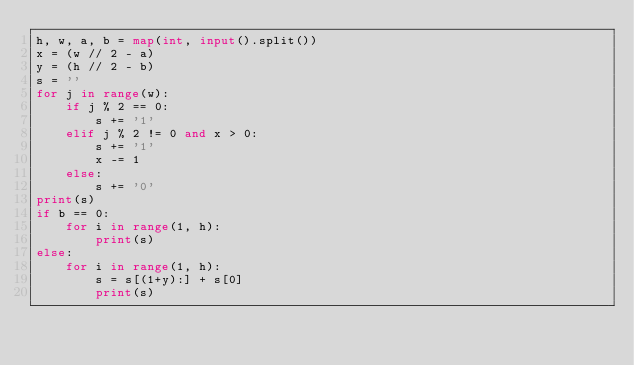<code> <loc_0><loc_0><loc_500><loc_500><_Python_>h, w, a, b = map(int, input().split())
x = (w // 2 - a)
y = (h // 2 - b)
s = ''
for j in range(w):
    if j % 2 == 0:
        s += '1'
    elif j % 2 != 0 and x > 0:
        s += '1'
        x -= 1
    else:
        s += '0'
print(s)
if b == 0:
    for i in range(1, h):
        print(s)
else:
    for i in range(1, h):
        s = s[(1+y):] + s[0]
        print(s)
</code> 